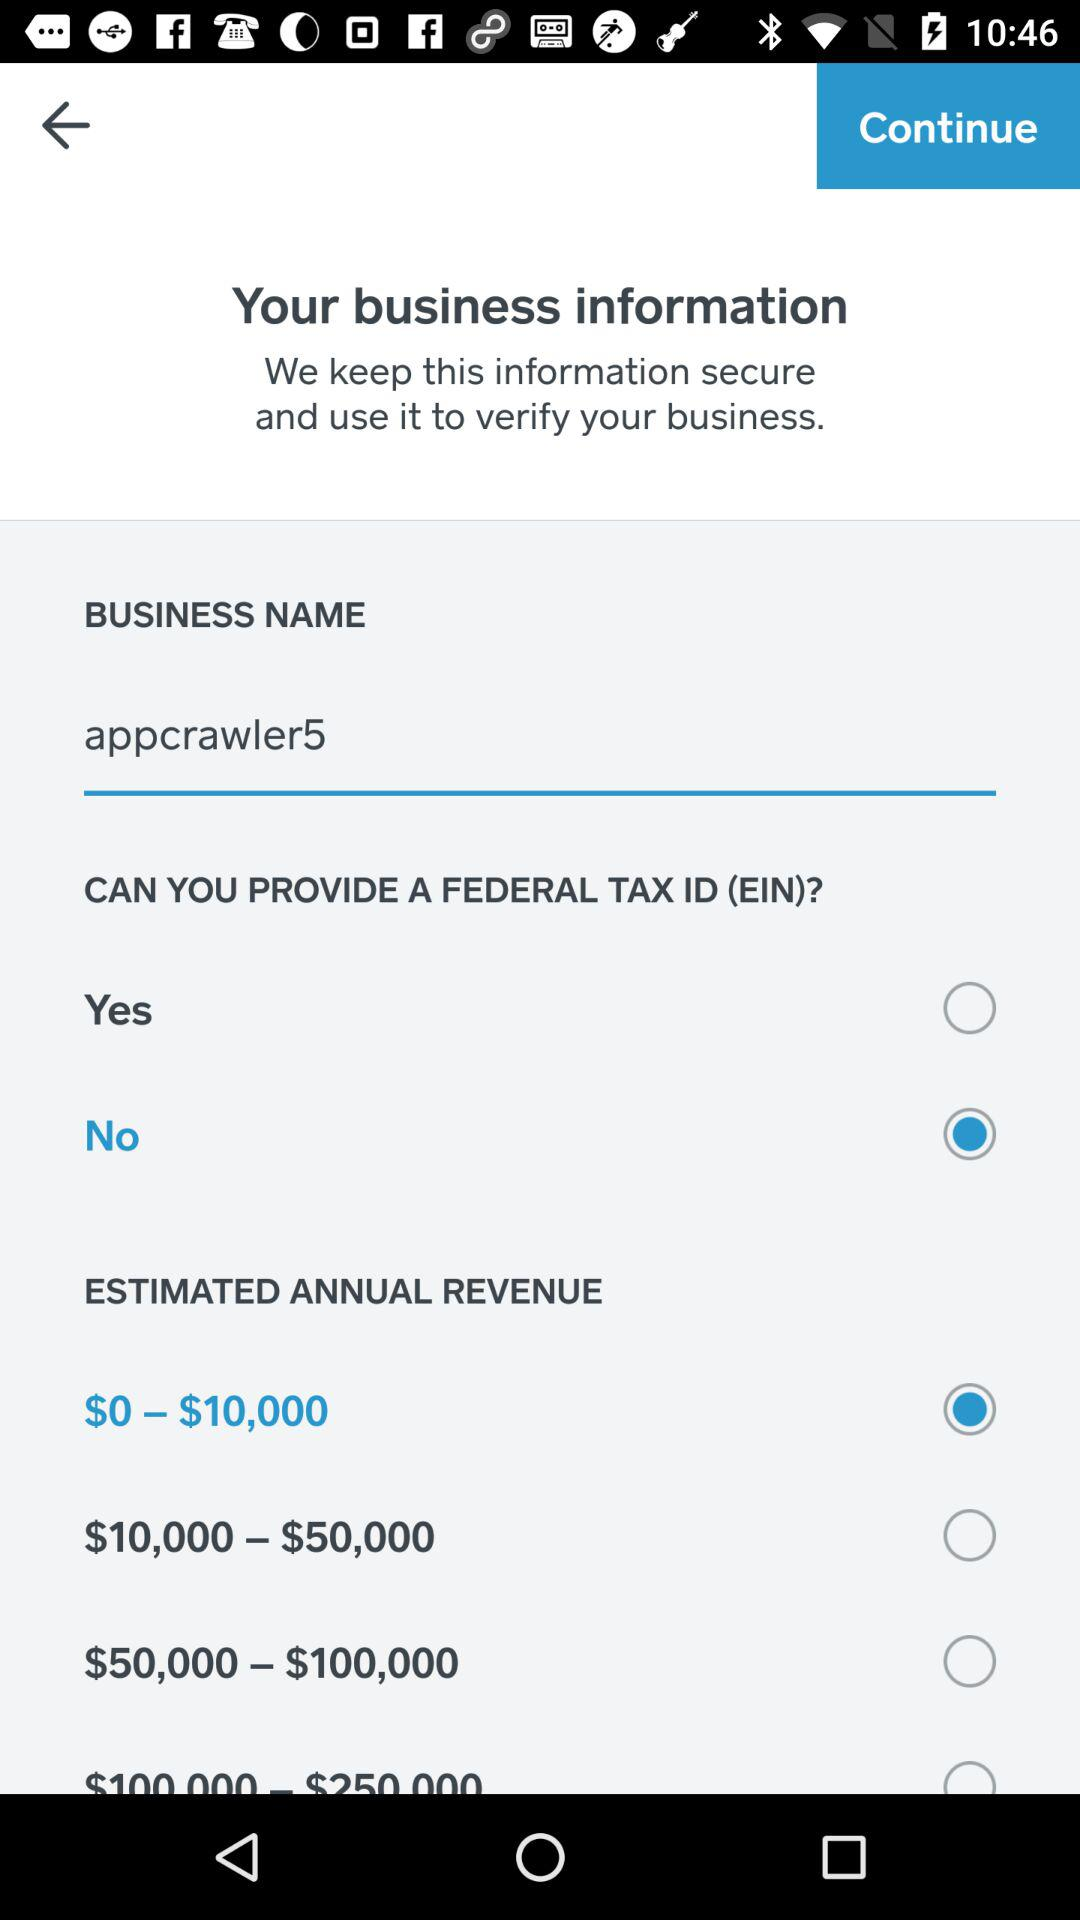What is the selected option in "ESTIMATED ANNUAL REVENUE"? The selected option in "ESTIMATED ANNUAL REVENUE" is "$0 – $10,000". 